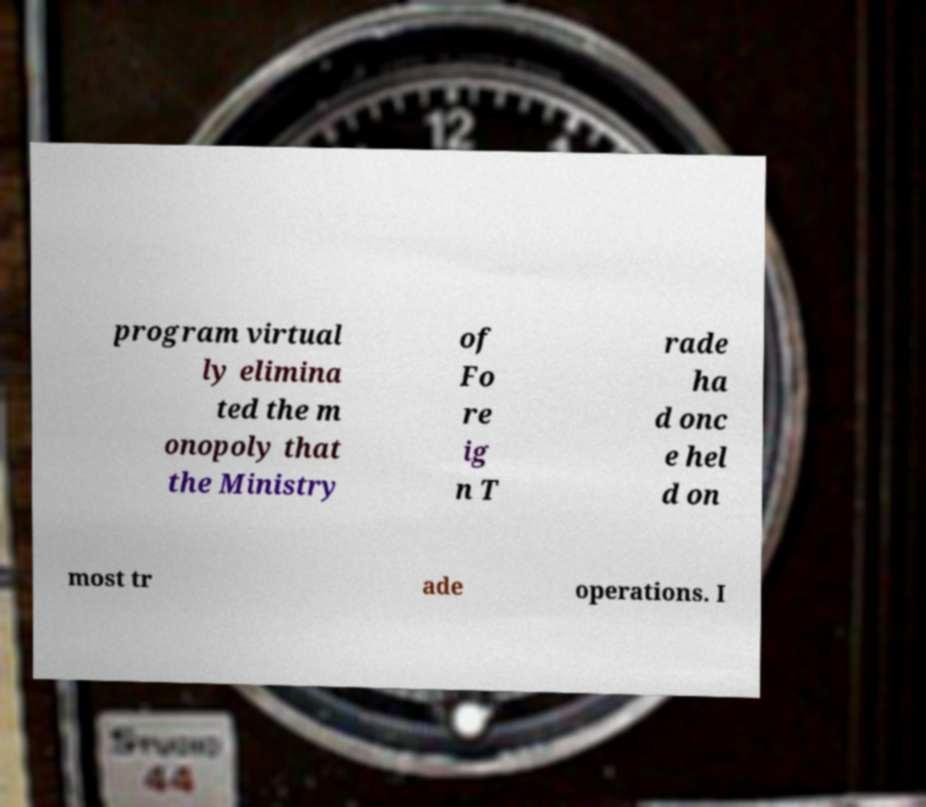Could you assist in decoding the text presented in this image and type it out clearly? program virtual ly elimina ted the m onopoly that the Ministry of Fo re ig n T rade ha d onc e hel d on most tr ade operations. I 